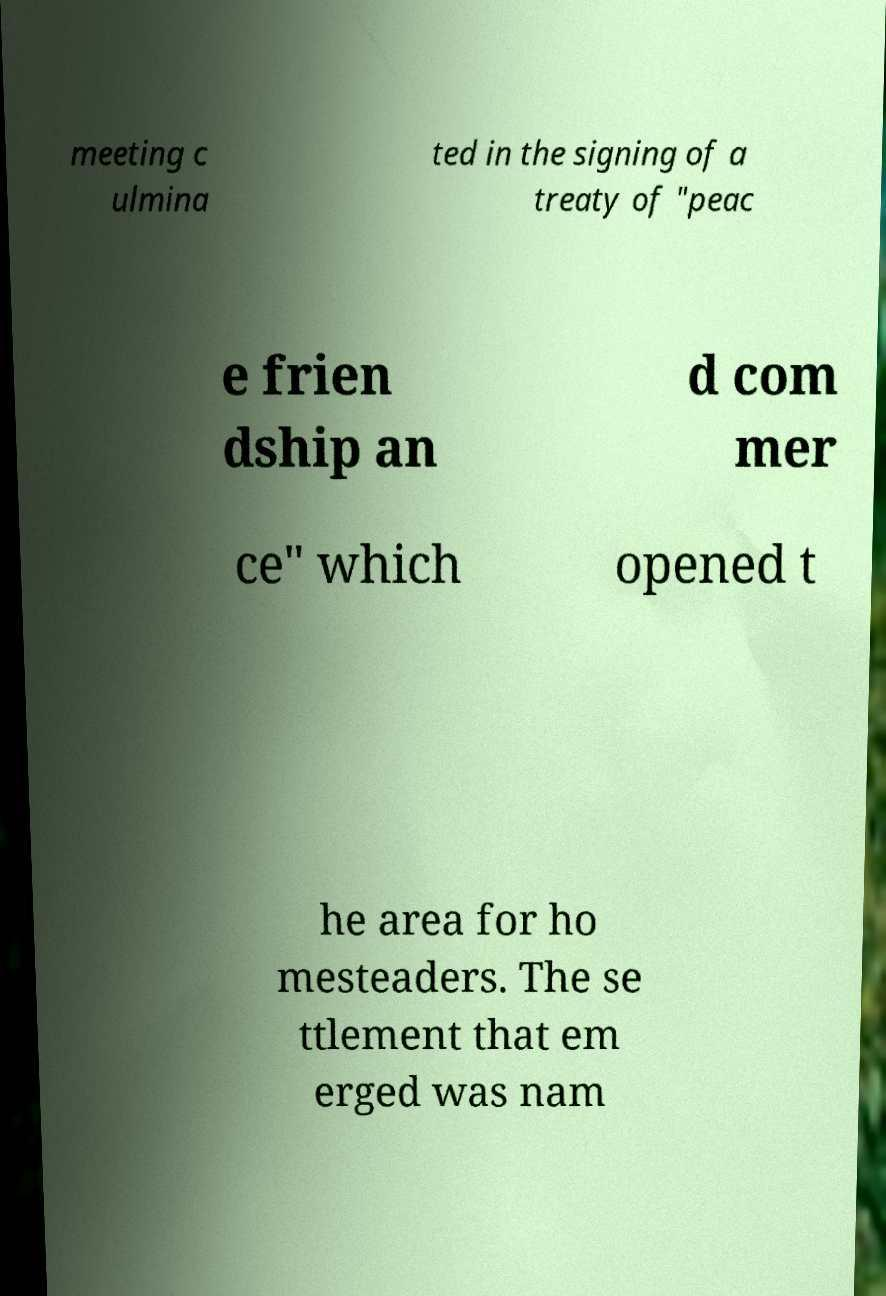What messages or text are displayed in this image? I need them in a readable, typed format. meeting c ulmina ted in the signing of a treaty of "peac e frien dship an d com mer ce" which opened t he area for ho mesteaders. The se ttlement that em erged was nam 